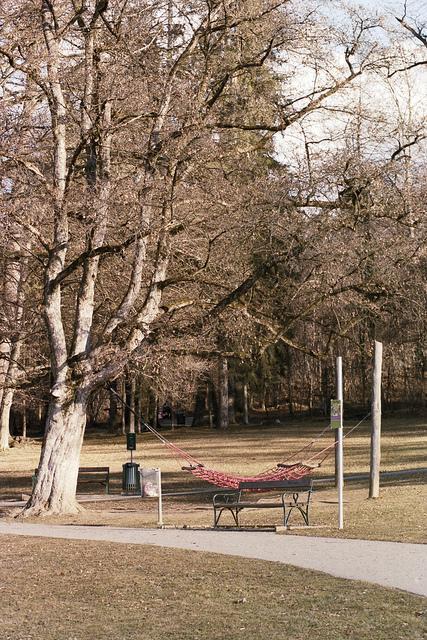How many benches are there?
Give a very brief answer. 2. How many people carry surfboard?
Give a very brief answer. 0. 